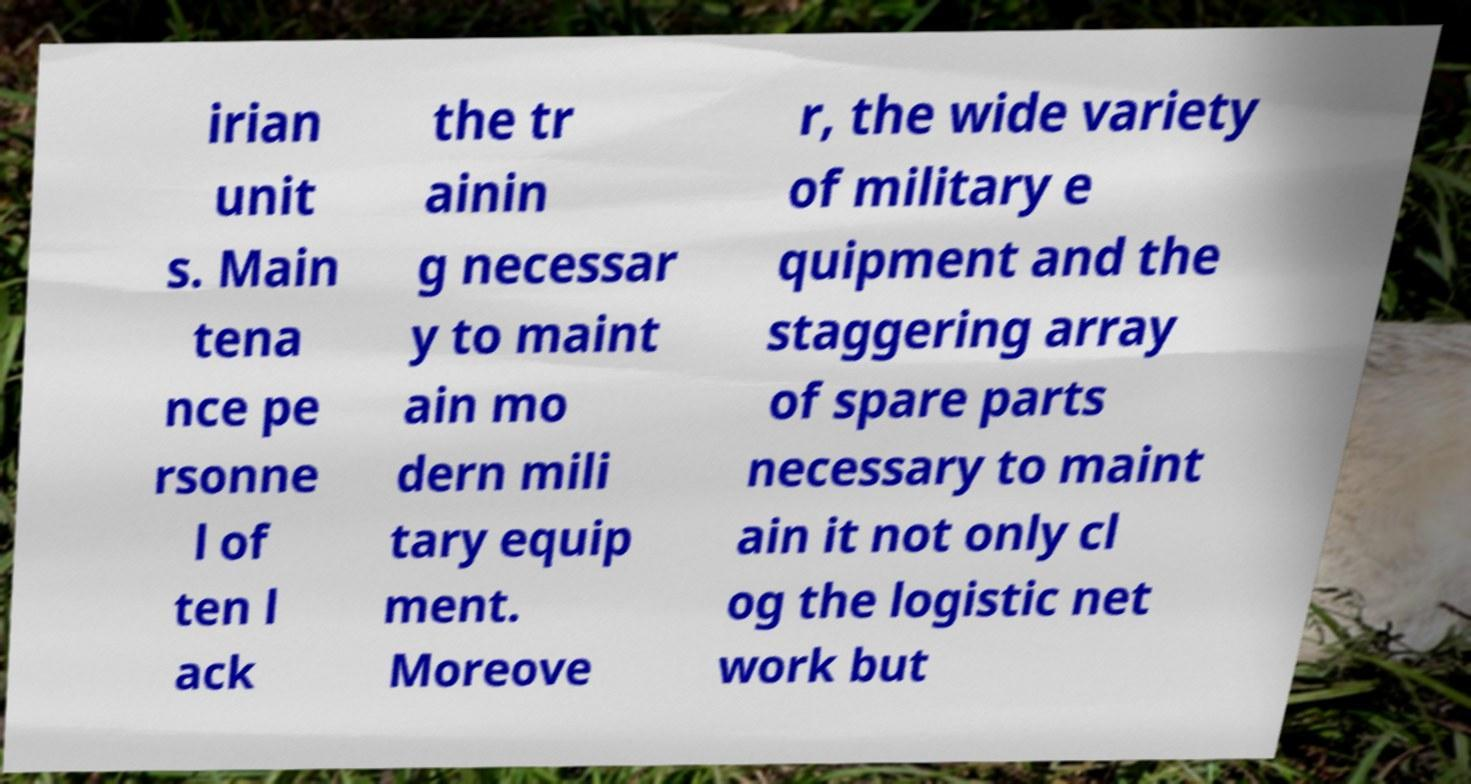What messages or text are displayed in this image? I need them in a readable, typed format. irian unit s. Main tena nce pe rsonne l of ten l ack the tr ainin g necessar y to maint ain mo dern mili tary equip ment. Moreove r, the wide variety of military e quipment and the staggering array of spare parts necessary to maint ain it not only cl og the logistic net work but 